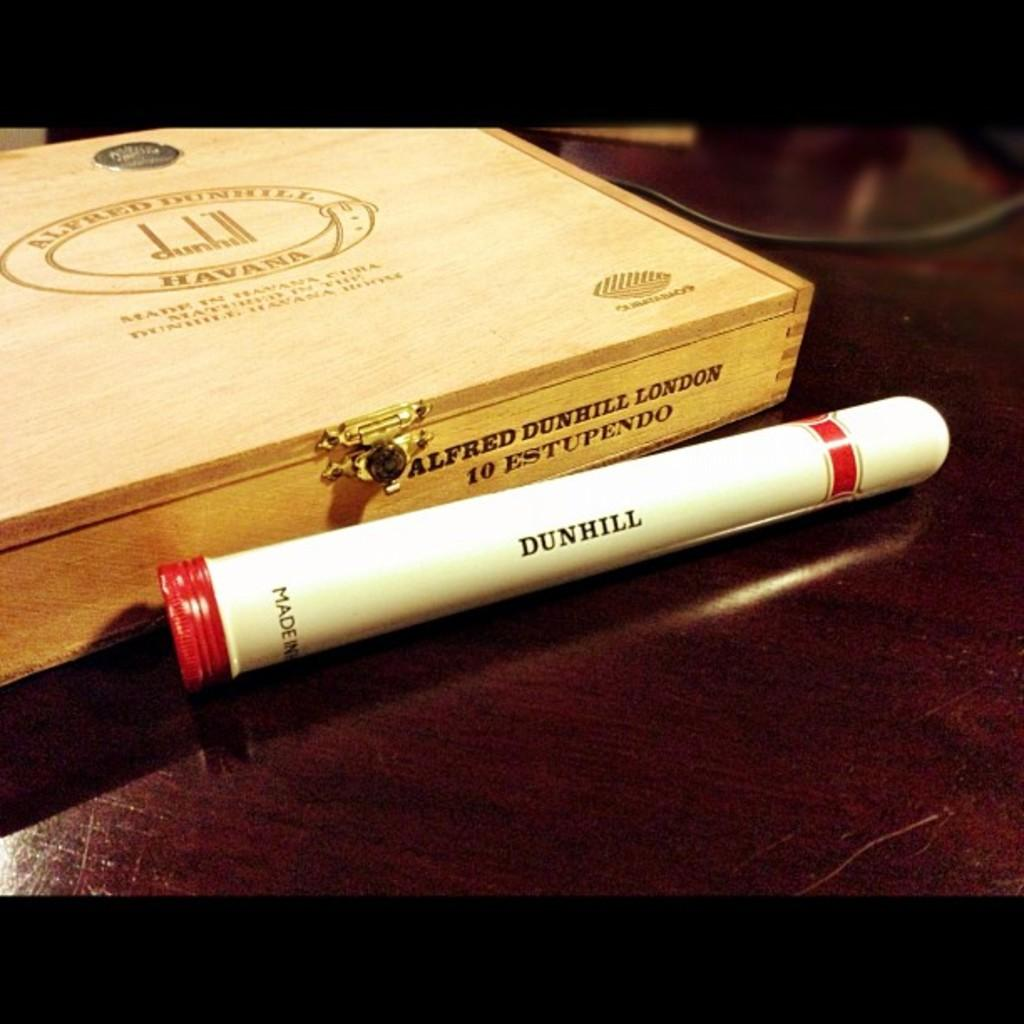<image>
Offer a succinct explanation of the picture presented. a cigar and cigar box placed on the table 